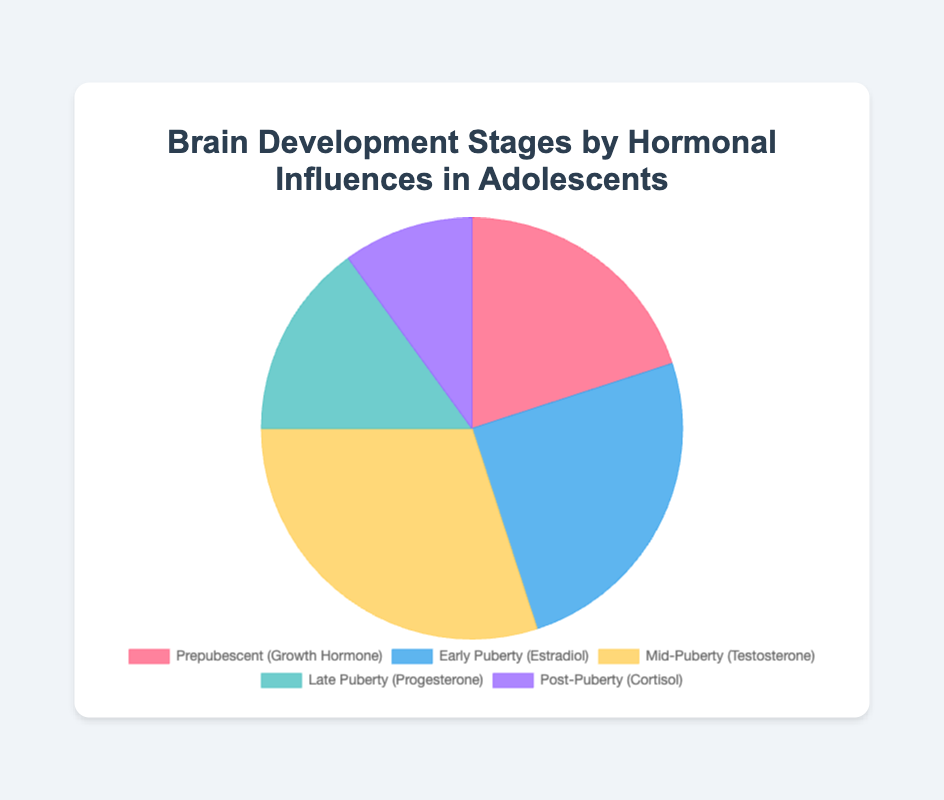What percentage of hormonal influence occurs during Mid-Puberty? By looking at the pie chart, we can see the segment labeled as Mid-Puberty is associated with 30%.
Answer: 30% Which stage has the lowest percentage of hormonal influence? Upon examining the pie chart, the segment representing Post-Puberty has the smallest size which corresponds to 10%.
Answer: Post-Puberty What is the total percentage of hormonal influence for Prepubescent and Early Puberty stages? By adding the percentages for Prepubescent (20%) and Early Puberty (25%), we get 20% + 25% = 45%.
Answer: 45% Compare the hormonal influence between Late Puberty and Post-Puberty stages. Which one is greater and by how much? The hormonal influence in Late Puberty (15%) is greater than in Post-Puberty (10%). The difference is 15% - 10% = 5%.
Answer: Late Puberty by 5% What is the average percentage influence across all the stages? Adding all percentages: 20% + 25% + 30% + 15% + 10% = 100%. There are 5 stages, so the average is 100% / 5 = 20%.
Answer: 20% Which stage shows the highest percentage of hormonal influence, and what hormone is associated with it? The pie chart segment for Mid-Puberty has the largest size and shows 30%, which is associated with Testosterone.
Answer: Mid-Puberty, Testosterone What is the combined influence of Cortisol and Progesterone on brain development, and in which stages do they occur? Cortisol occurs in Post-Puberty with 10% and Progesterone in Late Puberty with 15%. Combined, they influence 10% + 15% = 25%.
Answer: 25% in Post-Puberty and Late Puberty Identify the segment of the chart that is represented by a purple color and determine its percentage influence. The purple color segment in the pie chart represents Post-Puberty with a percentage of 10%.
Answer: Post-Puberty, 10% 